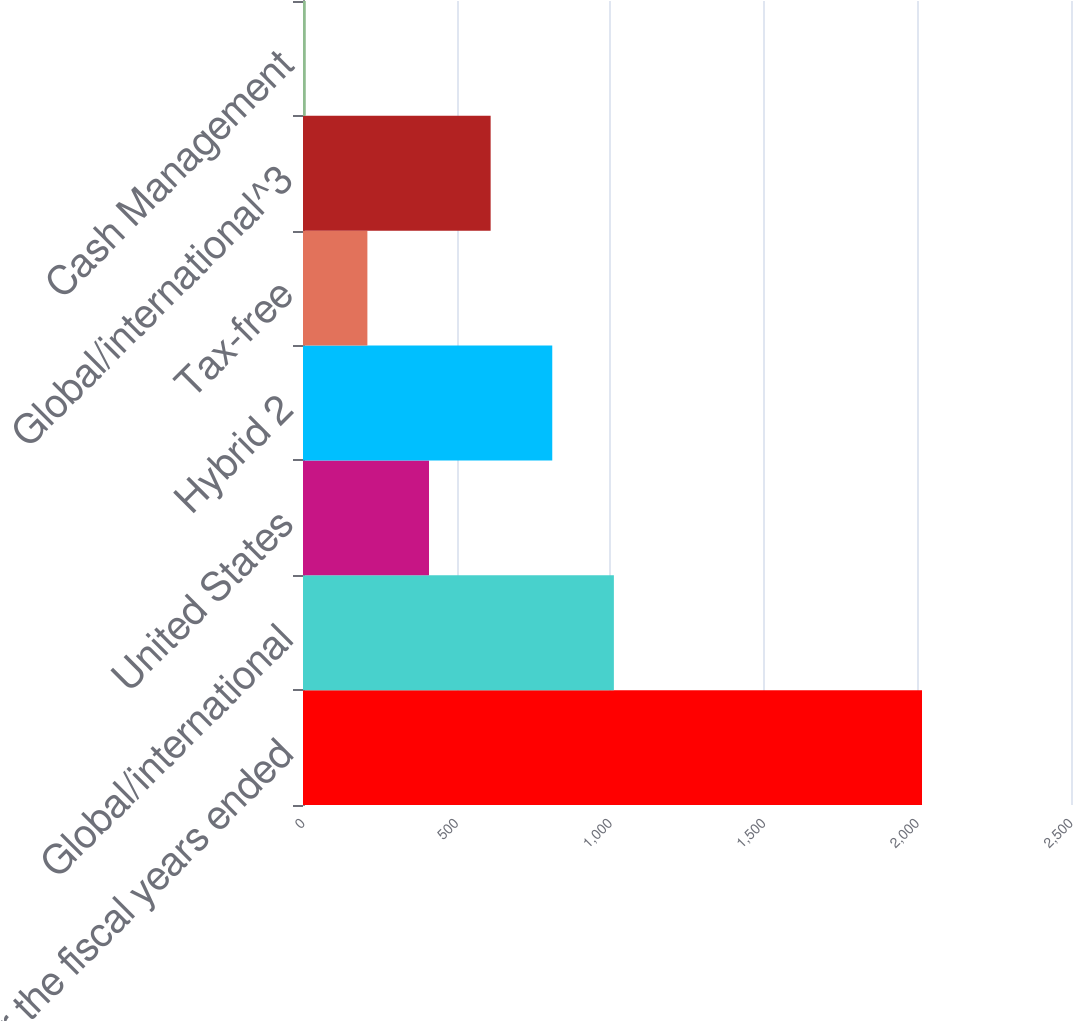<chart> <loc_0><loc_0><loc_500><loc_500><bar_chart><fcel>for the fiscal years ended<fcel>Global/international<fcel>United States<fcel>Hybrid 2<fcel>Tax-free<fcel>Global/international^3<fcel>Cash Management<nl><fcel>2015<fcel>1012<fcel>410.2<fcel>811.4<fcel>209.6<fcel>610.8<fcel>9<nl></chart> 